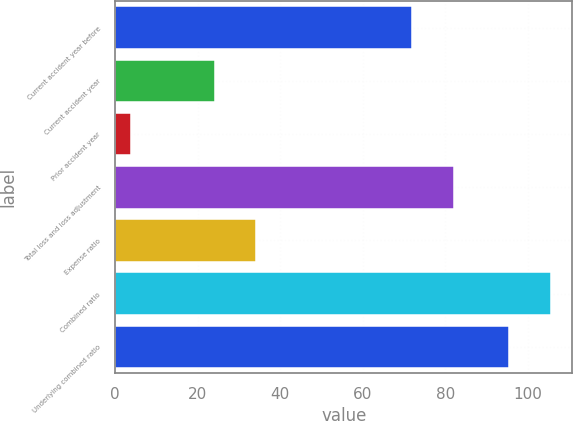<chart> <loc_0><loc_0><loc_500><loc_500><bar_chart><fcel>Current accident year before<fcel>Current accident year<fcel>Prior accident year<fcel>Total loss and loss adjustment<fcel>Expense ratio<fcel>Combined ratio<fcel>Underlying combined ratio<nl><fcel>72<fcel>24.08<fcel>3.9<fcel>82.09<fcel>34.17<fcel>105.49<fcel>95.4<nl></chart> 